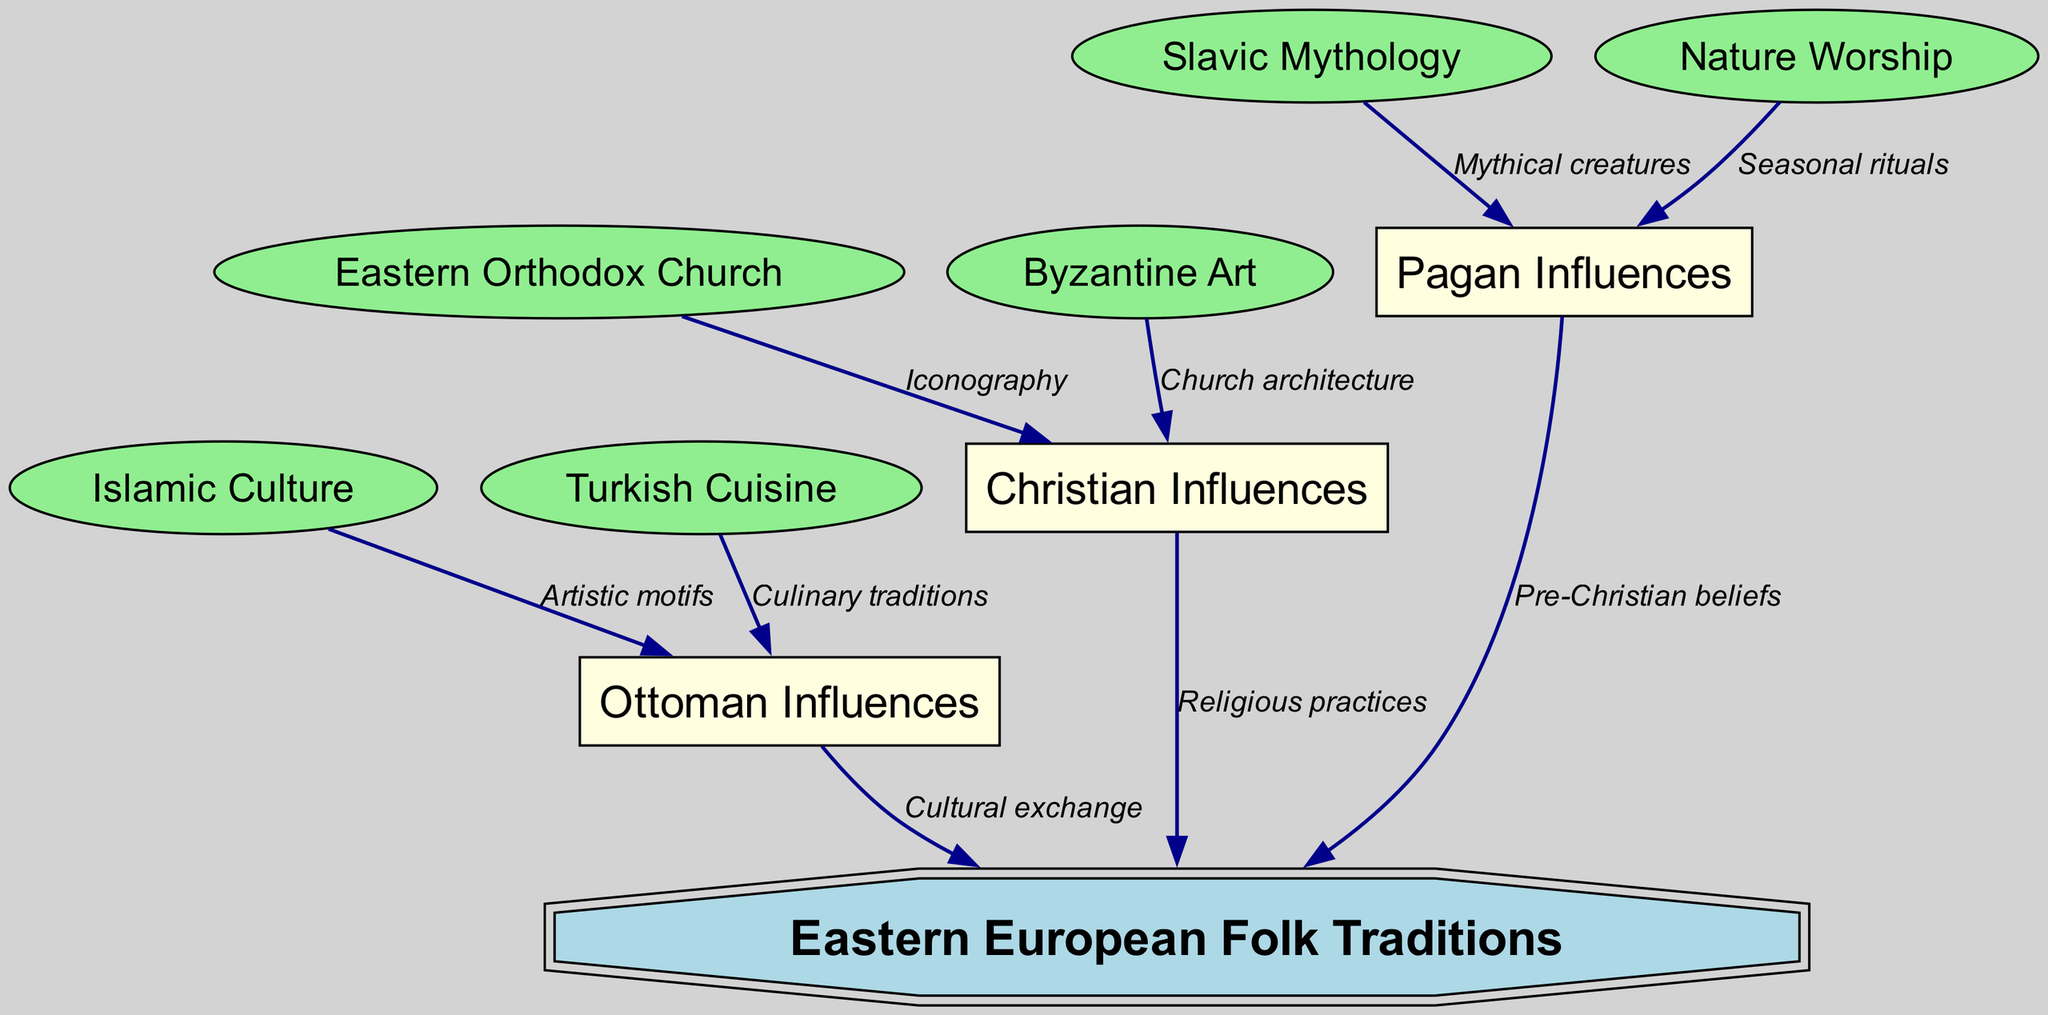What is the central topic of the diagram? The title of the main node in the diagram is "Eastern European Folk Traditions," indicating that this is the central theme around which all other elements are organized.
Answer: Eastern European Folk Traditions How many main influence categories are represented in the diagram? The diagram includes three main influence categories: Pagan Influences, Christian Influences, and Ottoman Influences. Counting these nodes gives us a total of three.
Answer: 3 What type of influences do "Byzantine Art" and "Eastern Orthodox Church" represent? Both "Byzantine Art" and "Eastern Orthodox Church" are connected to the "Christian Influences" node. This indicates that they represent subcategories or elements that contribute to Christian influence in Eastern European folk traditions.
Answer: Christian influences Which node is directly connected to "Islamic Culture"? "Islamic Culture" has a direct edge to "Ottoman Influences" labeled as "Artistic motifs," indicating that it contributes to the Ottoman influence in Eastern Europe.
Answer: Ottoman Influences What is the relationship between "Slavic Mythology" and "Pagan Influences"? "Slavic Mythology" connects to "Pagan Influences" through the edge labeled "Mythical creatures," demonstrating that Slavic mythology is a traditional aspect that embodies pagan elements.
Answer: Mythical creatures How many edges connect to "Eastern Orthodox Church"? The "Eastern Orthodox Church" node has one outgoing edge that connects to "Christian Influences" with the label "Iconography," showing its contribution to the broader category of Christian influence.
Answer: 1 What element indicates a seasonal aspect within "Pagan Influences"? The node "Nature Worship" is linked to "Pagan Influences" with the label "Seasonal rituals," indicating that it represents practices related to the changing seasons, a key element in pagan traditions.
Answer: Seasonal rituals What culinary tradition is associated with Ottoman influences in the diagram? "Turkish Cuisine" is directly connected to "Ottoman Influences" through an edge labeled "Culinary traditions," which shows its relation to Ottoman culture.
Answer: Turkish Cuisine What type of artistic element is listed under "Christian Influences"? The diagram points to "Church architecture" as a significant artistic element associated with "Christian Influences." This clearly represents how Eastern European folk traditions integrate church-building traditions and styles.
Answer: Church architecture 